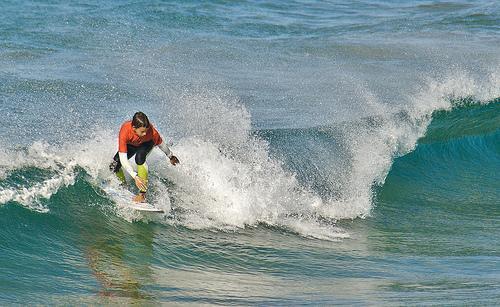How many people are in the picture?
Give a very brief answer. 1. 